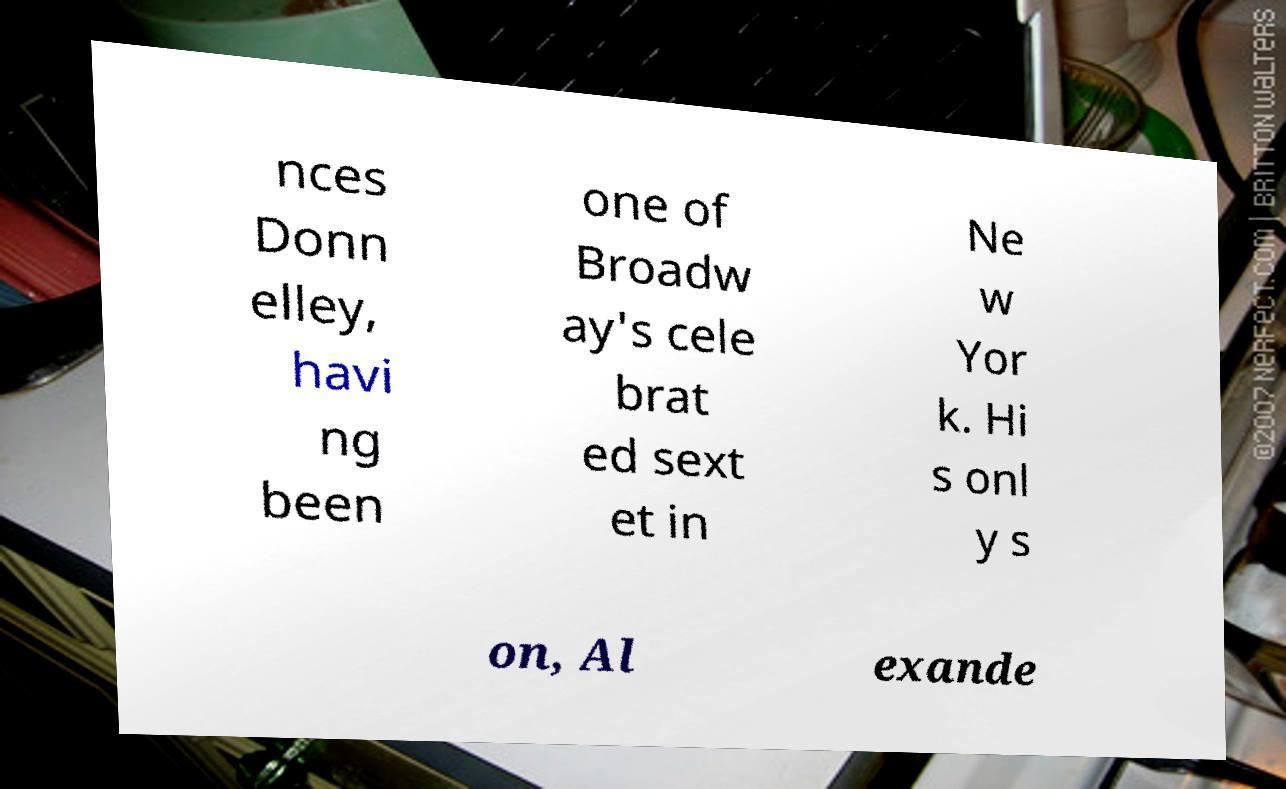Can you read and provide the text displayed in the image?This photo seems to have some interesting text. Can you extract and type it out for me? nces Donn elley, havi ng been one of Broadw ay's cele brat ed sext et in Ne w Yor k. Hi s onl y s on, Al exande 